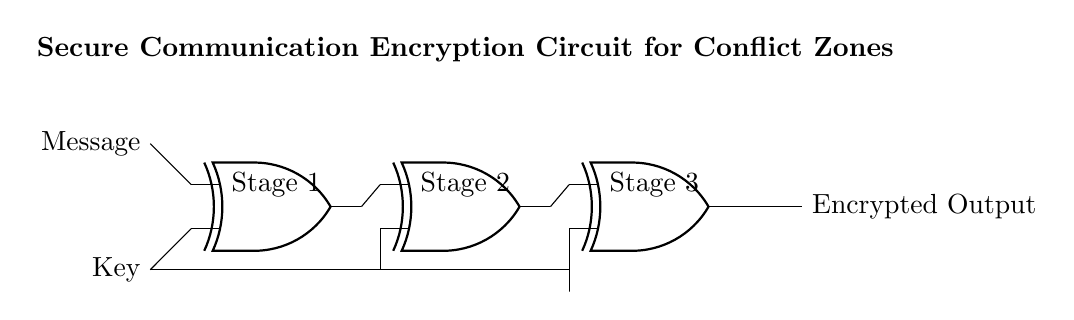What is the main function of the circuit? The main function of the circuit is to encrypt messages using a key, ensuring secure communication. This is facilitated by the arrangement of the XOR gates which perform an exclusive OR operation on the input signals.
Answer: Encrypting messages How many XOR gates are used in the circuit? There are three XOR gates shown in the circuit diagram, labeled as Stage 1, Stage 2, and Stage 3. Each of these gates processes the signals from the previous stage.
Answer: Three What type of logic gate is utilized in this circuit? The circuit utilizes XOR (exclusive OR) gates specifically, which are designed to output true only when an odd number of inputs are true.
Answer: XOR What do the inputs to the first XOR gate represent? The inputs to the first XOR gate represent the original message and the encryption key, which are combined to produce an encrypted output in subsequent stages.
Answer: Message and Key What is the output of the final XOR gate labeled as? The output of the final XOR gate is referred to as the "Encrypted Output" which results from the series of XOR operations on the input signals.
Answer: Encrypted Output How does the circuit ensure that multiple keys are used in encryption? The circuit ensures multiple keys are used by distributing the same key to the second and third XOR gates, which helps in creating different layers of encryption through successive XOR operations.
Answer: Key distribution 